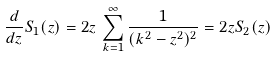Convert formula to latex. <formula><loc_0><loc_0><loc_500><loc_500>\frac { d } { d z } S _ { 1 } ( z ) = 2 z \, \sum _ { k = 1 } ^ { \infty } \frac { 1 } { ( k ^ { 2 } - z ^ { 2 } ) ^ { 2 } } = 2 z S _ { 2 } ( z )</formula> 